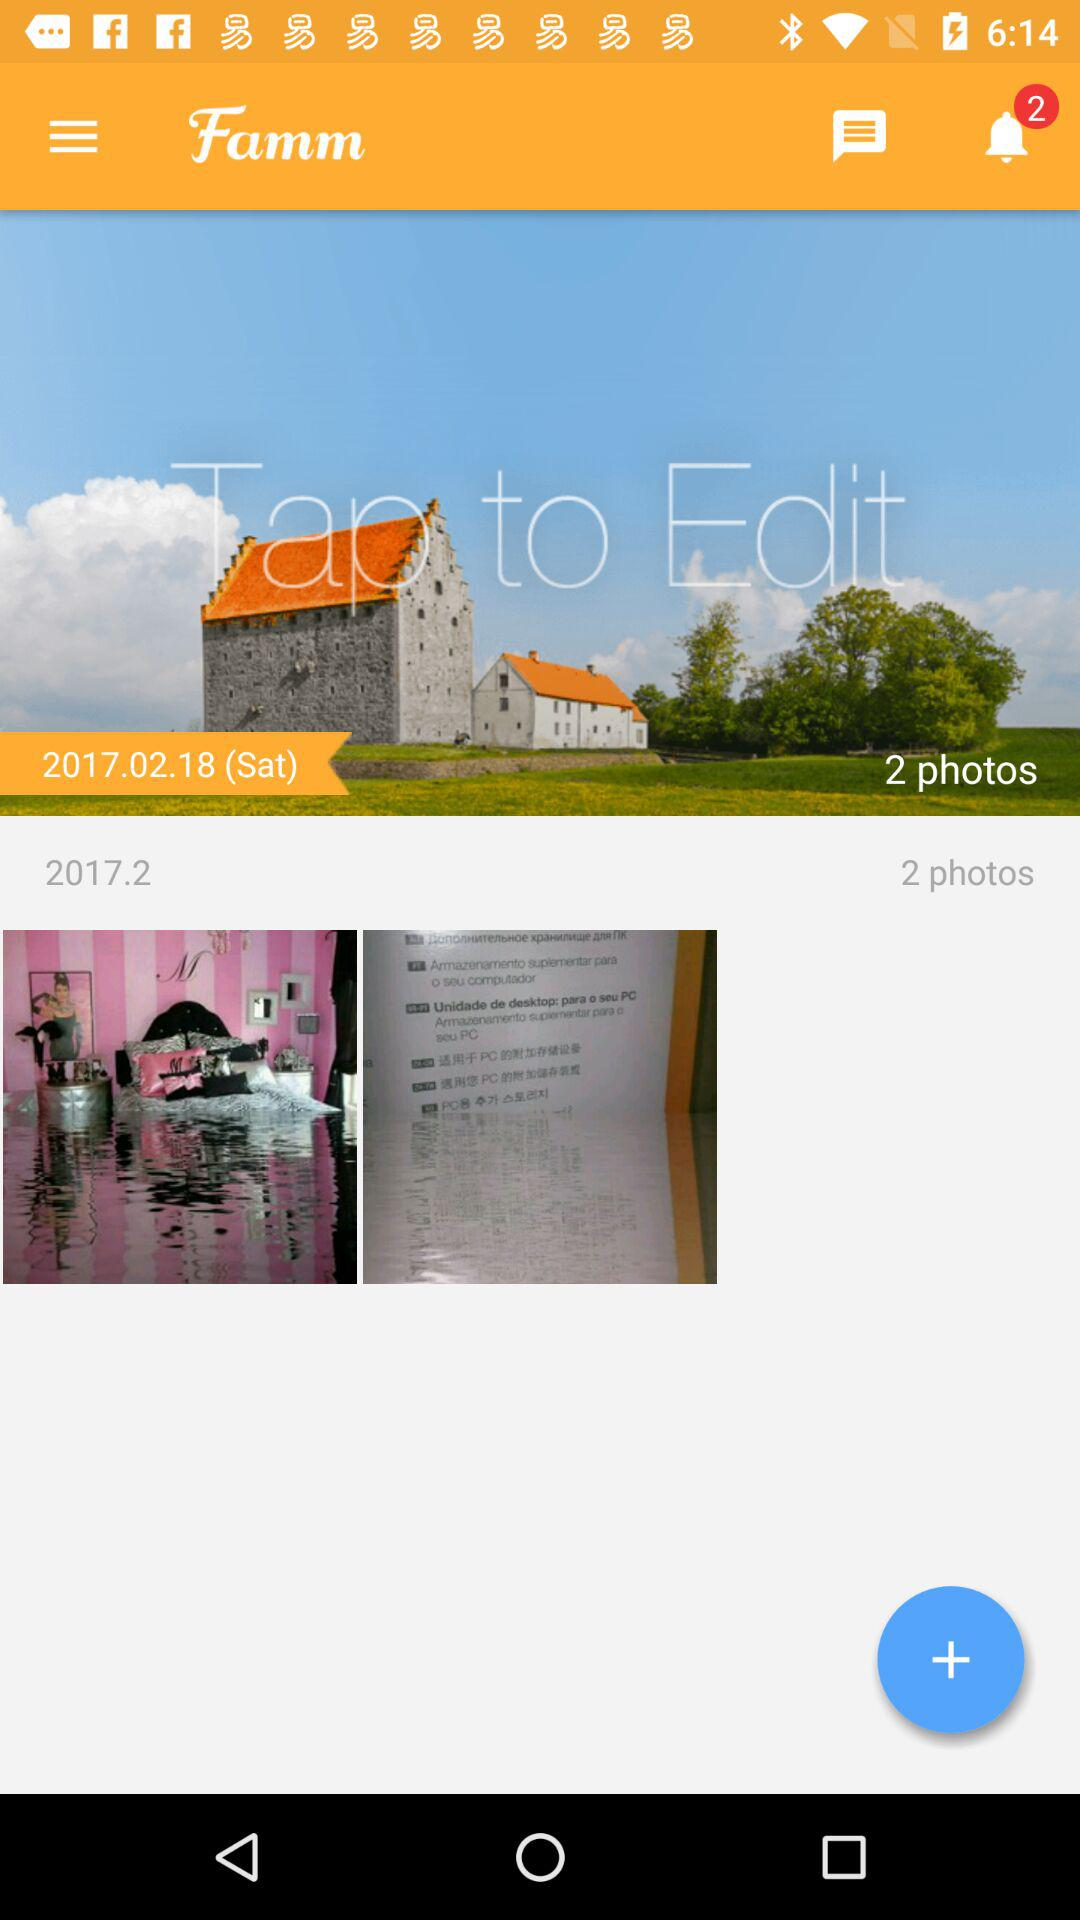How many photos are in this album?
Answer the question using a single word or phrase. 2 